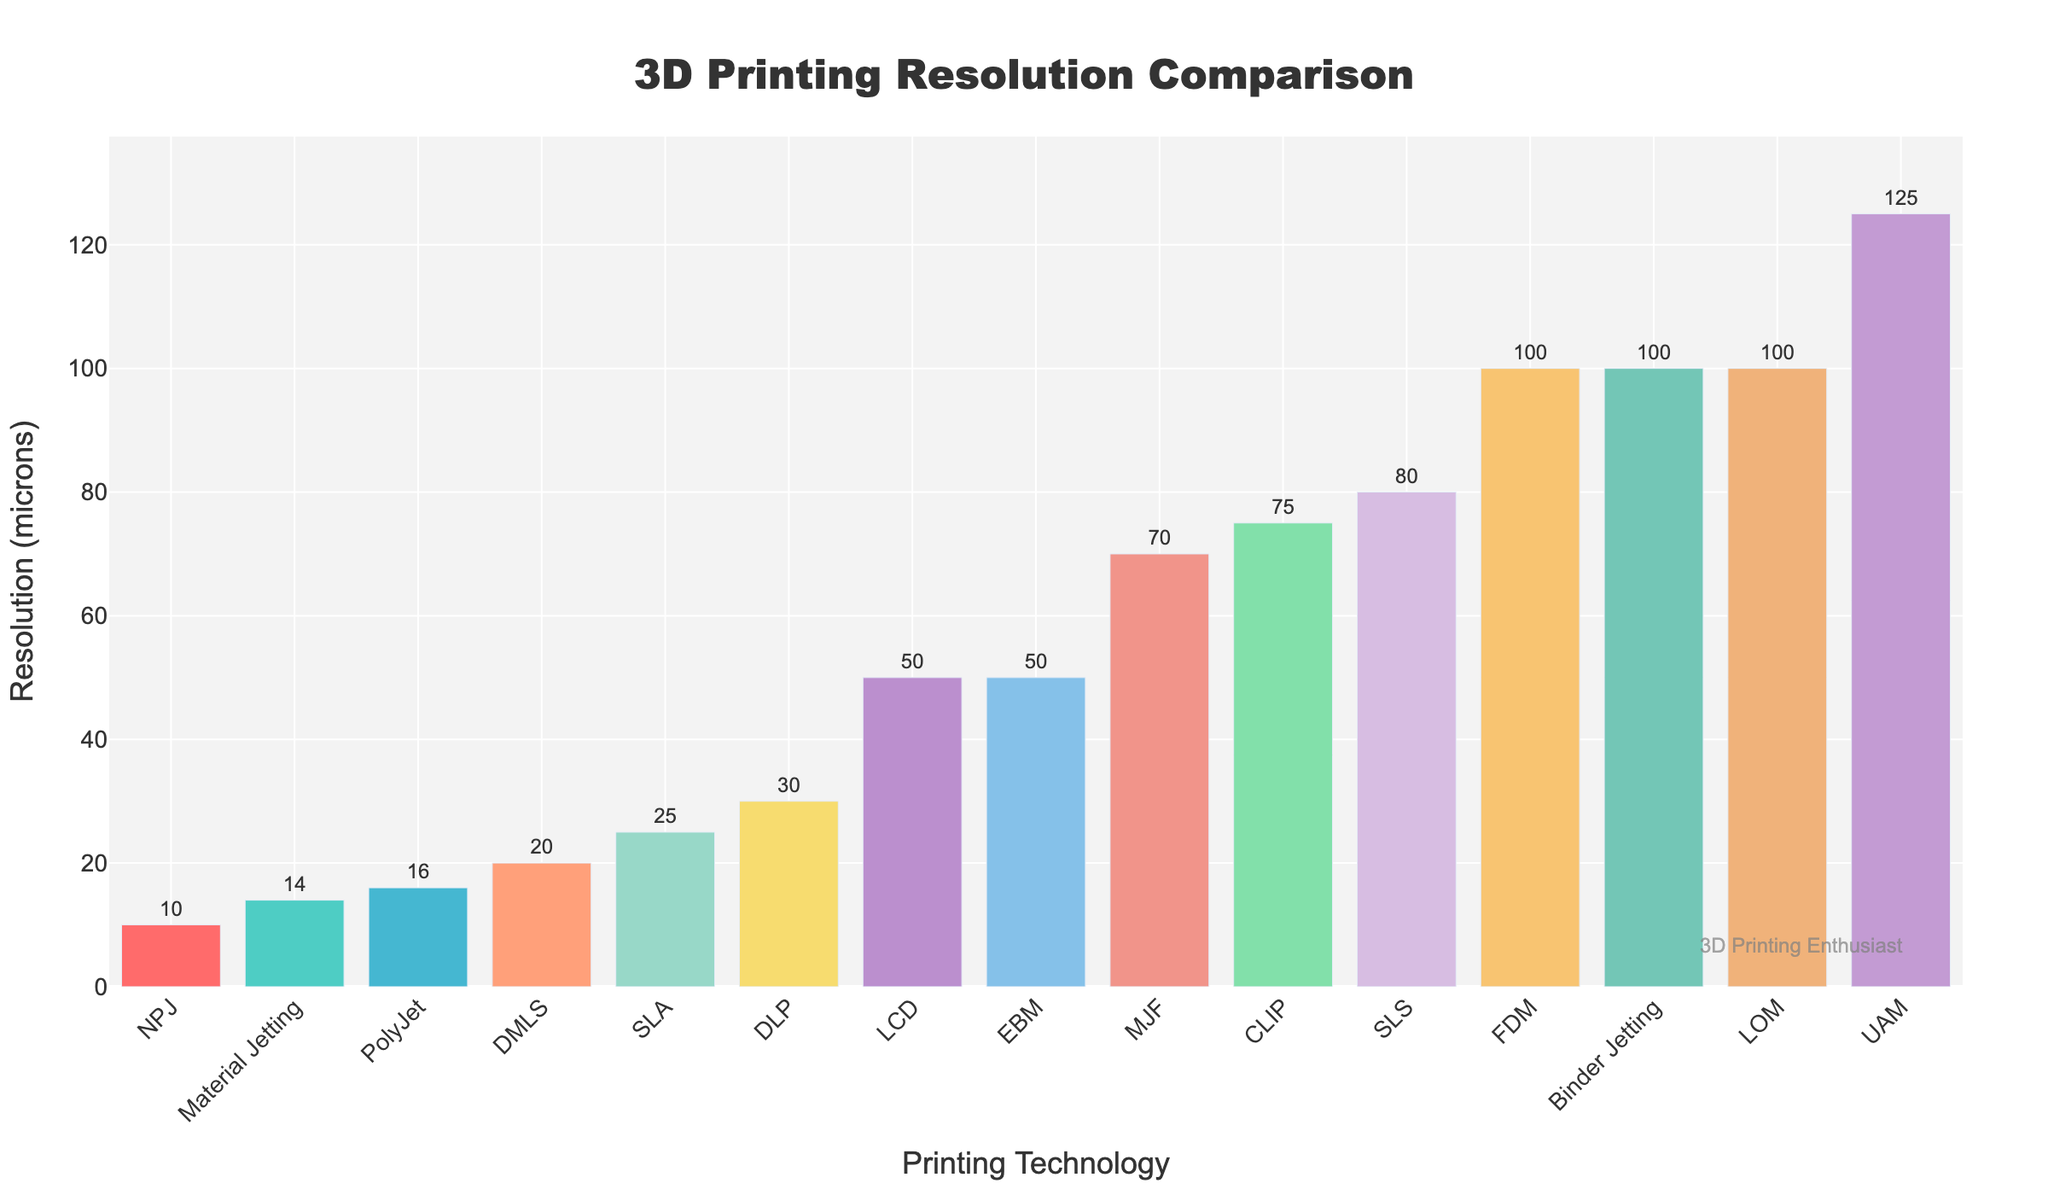What 3D printing technology has the smallest resolution (in microns)? Look at the bar chart and find the bar with the lowest position on the y-axis. The technology corresponding to this bar is the one with the smallest resolution.
Answer: NPJ What technologies have a resolution of exactly 100 microns? Identify all bars that are positioned at the 100 microns mark on the y-axis.
Answer: FDM, Binder Jetting, LOM How much higher is the resolution of SLS compared to CLIP? Find the resolution values for both SLS and CLIP and subtract the resolution value of CLIP from that of SLS (80 - 75).
Answer: 5 microns Which technology has a lower resolution, EBM or LCD? Compare the height of the bars for EBM and LCD. The bar that is lower on the y-axis represents the technology with a lower resolution.
Answer: EBM Which technology has the highest resolution and what is the value? Look for the technology with the lowest bar on the y-axis, indicating the smallest micron value, and note the value displayed.
Answer: NPJ, 10 microns What is the difference in resolution between PolyJet and Material Jetting? Determine the resolution values for PolyJet (16 microns) and Material Jetting (14 microns) and calculate their difference (16 - 14).
Answer: 2 microns On average, do printing technologies have resolutions higher or lower than 50 microns? Calculate the average of all the resolution values listed and compare it to 50 microns. ([100 + 25 + 30 + 80 + 16 + 20 + 100 + 14 + 50 + 75 + 50 + 100 + 70 + 10 + 125] / 15 ≈ 56.6).
Answer: Higher How many technologies have a resolution of less than 30 microns? Count the number of bars representing technologies with y-axis values less than 30 microns.
Answer: 4 What are the colors used for the technologies with the highest and lowest resolutions? Look at the color of the bars representing NPJ (lowest resolution) and UAM (highest resolution).
Answer: Blue (lowest, NPJ), purple (highest, UAM) Which has a finer resolution, SLA or DLP? Compare the resolution values of SLA (25 microns) and DLP (30 microns). The technology with the lower value has the finer resolution.
Answer: SLA 